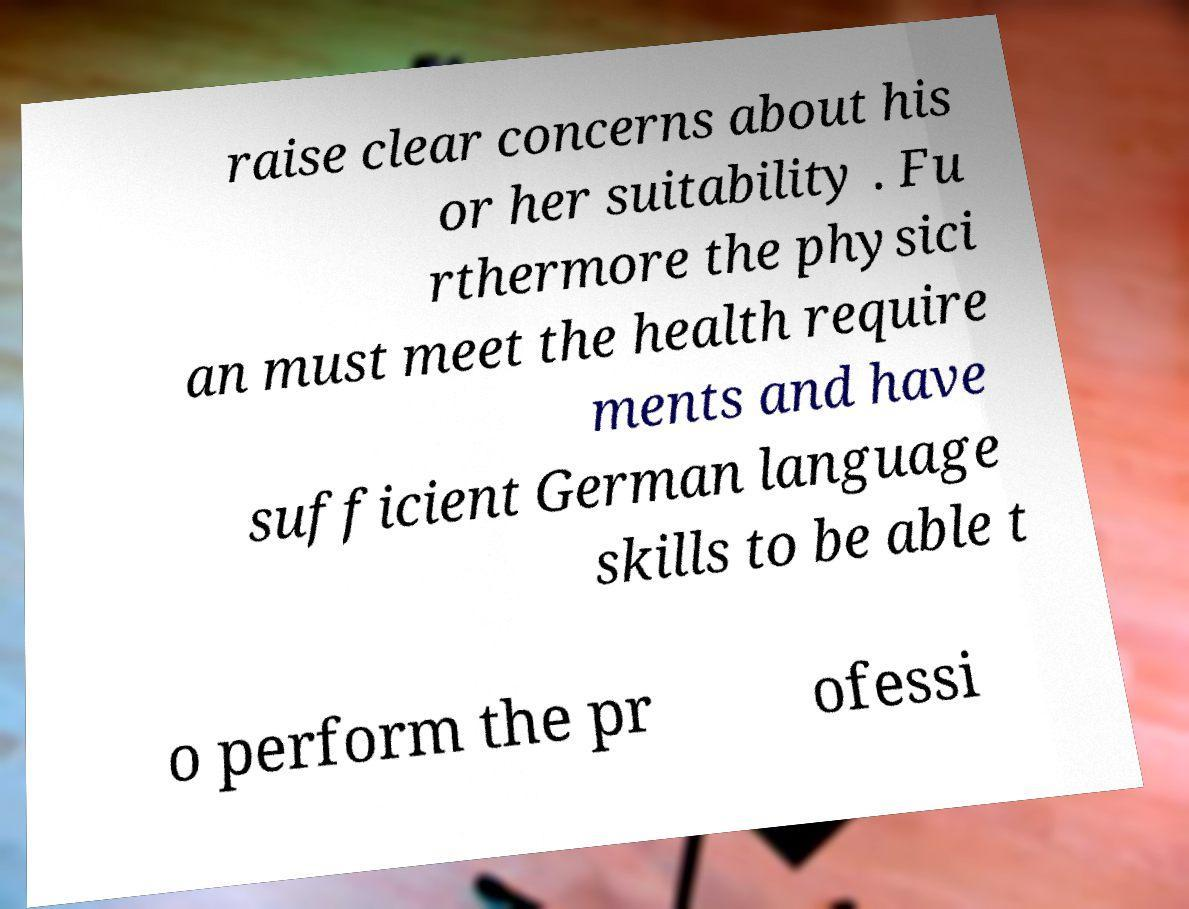What messages or text are displayed in this image? I need them in a readable, typed format. raise clear concerns about his or her suitability . Fu rthermore the physici an must meet the health require ments and have sufficient German language skills to be able t o perform the pr ofessi 